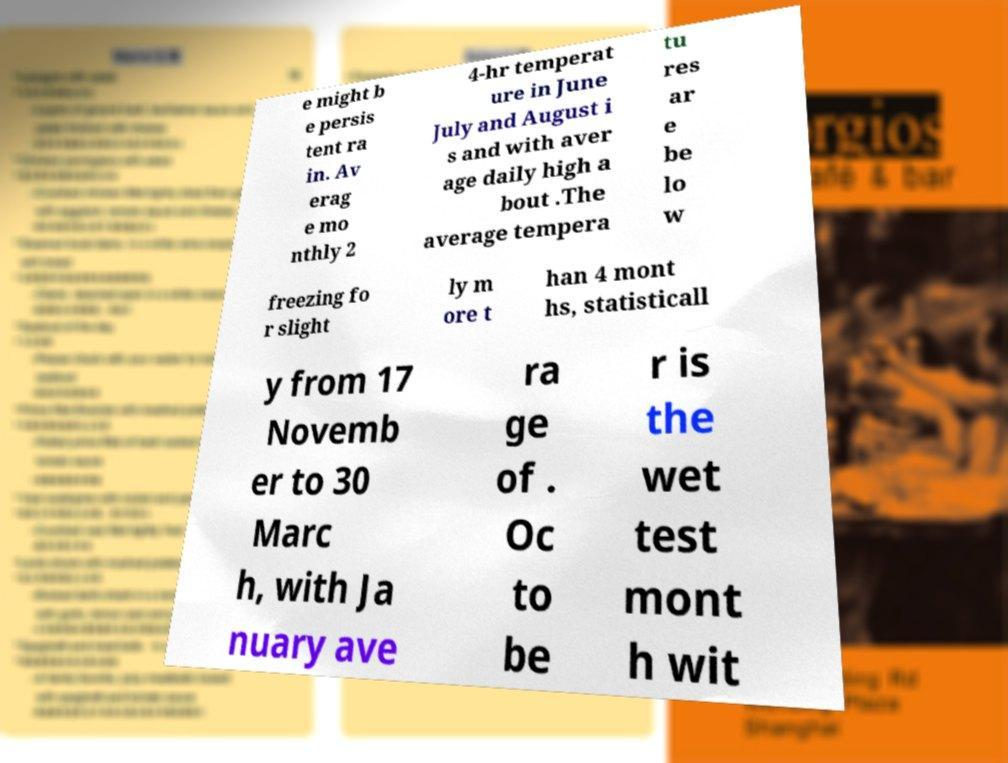For documentation purposes, I need the text within this image transcribed. Could you provide that? e might b e persis tent ra in. Av erag e mo nthly 2 4-hr temperat ure in June July and August i s and with aver age daily high a bout .The average tempera tu res ar e be lo w freezing fo r slight ly m ore t han 4 mont hs, statisticall y from 17 Novemb er to 30 Marc h, with Ja nuary ave ra ge of . Oc to be r is the wet test mont h wit 